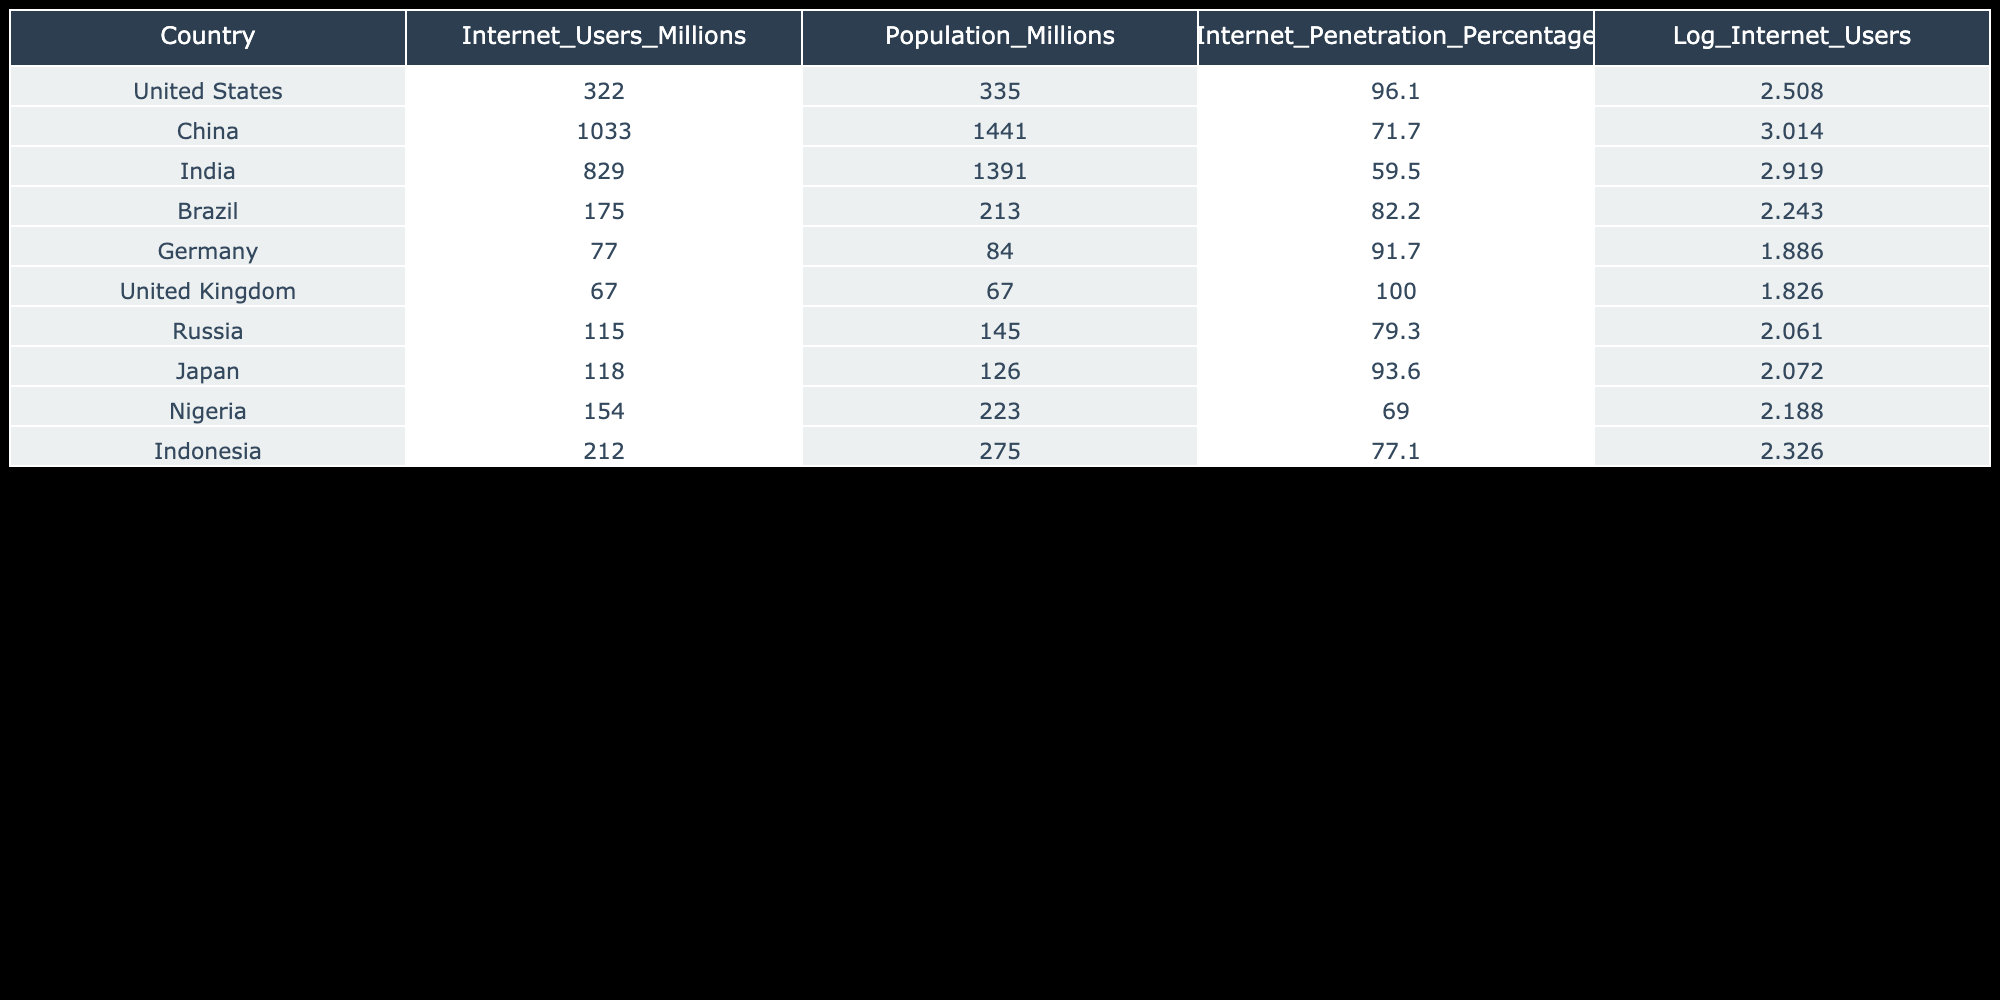What is the Internet penetration percentage of India? The internet penetration percentage of India is stated directly in the table under the "Internet_Penetration_Percentage" column.
Answer: 59.5 Which country has the highest number of internet users in millions? By looking at the "Internet_Users_Millions" column, China has the highest value with 1033 million users.
Answer: China What is the logarithmic value of internet users for Nigeria? The logarithmic value for Nigeria is provided in the "Log_Internet_Users" column, which shows a value of 5.058.
Answer: 5.058 Calculate the total internet users (in millions) for the top three countries listed. The top three countries by internet users are China (1033), India (829), and the United States (322). Adding these gives: 1033 + 829 + 322 = 2184 million.
Answer: 2184 Is the internet penetration percentage in the United Kingdom higher than that of Germany? The table shows that the United Kingdom has an internet penetration percentage of 100.0%, while Germany has 91.7%. Since 100.0% is greater than 91.7%, the answer is yes.
Answer: Yes What is the difference in the number of internet users (in millions) between the highest and the lowest country shown in the table? The highest number of internet users is in China (1033 million) and the lowest is in Germany (77 million). The difference is calculated as 1033 - 77 = 956 million.
Answer: 956 Which country has an internet penetration percentage below 70%? By examining the "Internet_Penetration_Percentage" column, India (59.5%) is the only country with an internet penetration percentage below 70%.
Answer: India Find the average number of internet users (in millions) for the countries listed. The total number of internet users for all the countries is 322 + 1033 + 829 + 175 + 77 + 67 + 115 + 118 + 154 + 212 = 3027 million. There are 10 countries, so the average is 3027 / 10 = 302.7 million.
Answer: 302.7 Is the internet penetration of Brazil higher than that of Russia? Brazil has an internet penetration percentage of 82.2% and Russia has 79.3%. Since 82.2% is greater than 79.3%, the answer is yes.
Answer: Yes 